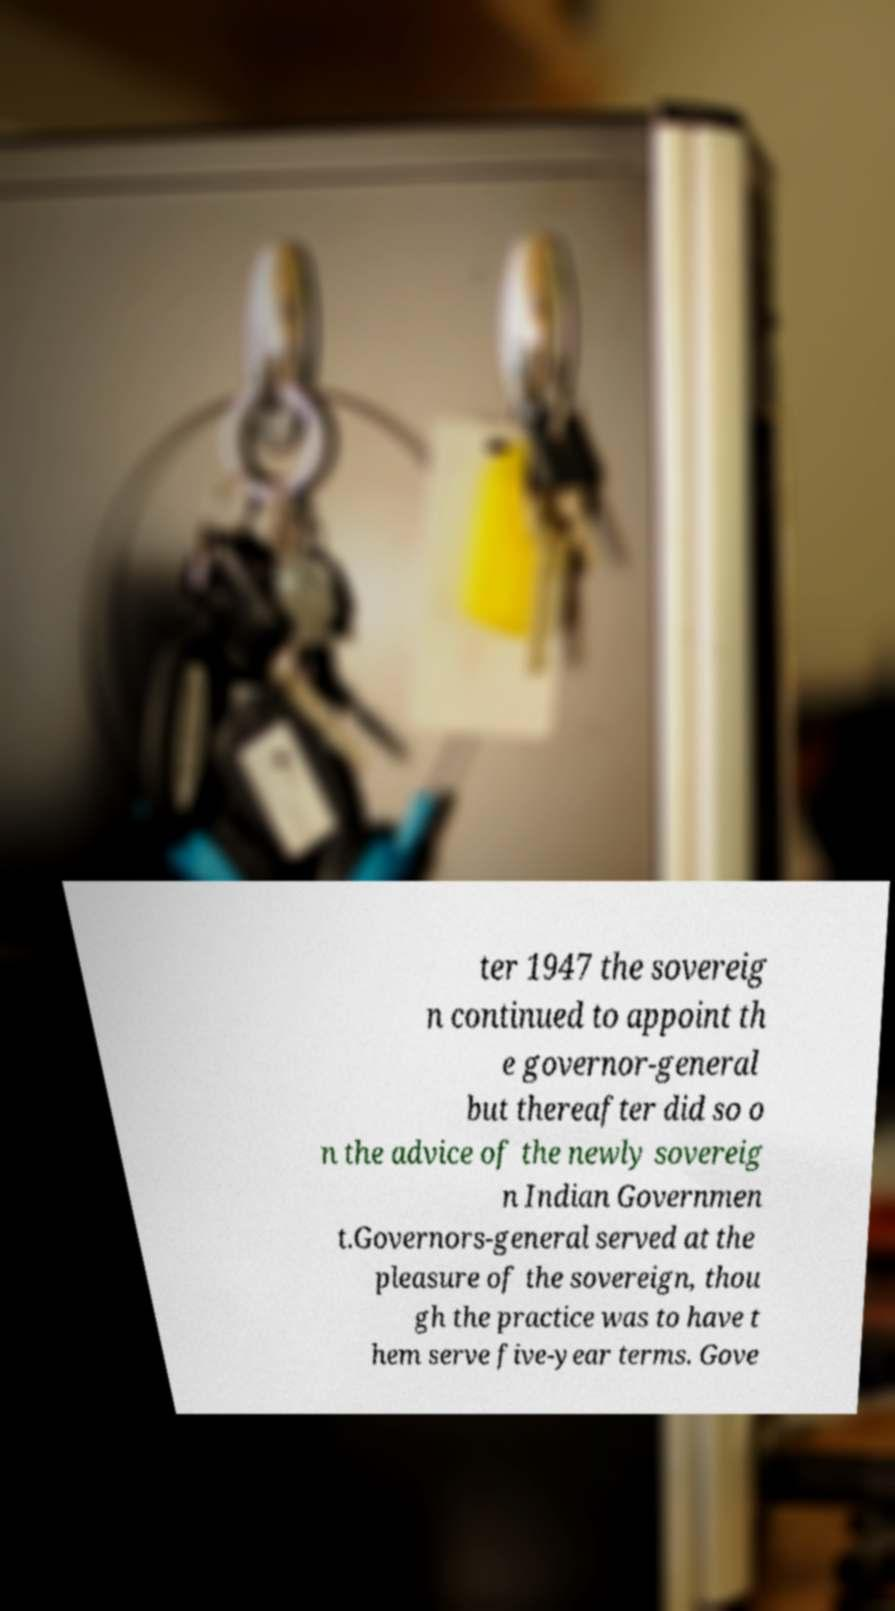For documentation purposes, I need the text within this image transcribed. Could you provide that? ter 1947 the sovereig n continued to appoint th e governor-general but thereafter did so o n the advice of the newly sovereig n Indian Governmen t.Governors-general served at the pleasure of the sovereign, thou gh the practice was to have t hem serve five-year terms. Gove 